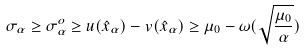<formula> <loc_0><loc_0><loc_500><loc_500>\sigma _ { \alpha } \geq \sigma ^ { o } _ { \alpha } \geq u ( \hat { x } _ { \alpha } ) - v ( \hat { x } _ { \alpha } ) \geq \mu _ { 0 } - \omega ( \sqrt { \frac { \mu _ { 0 } } { \alpha } } )</formula> 